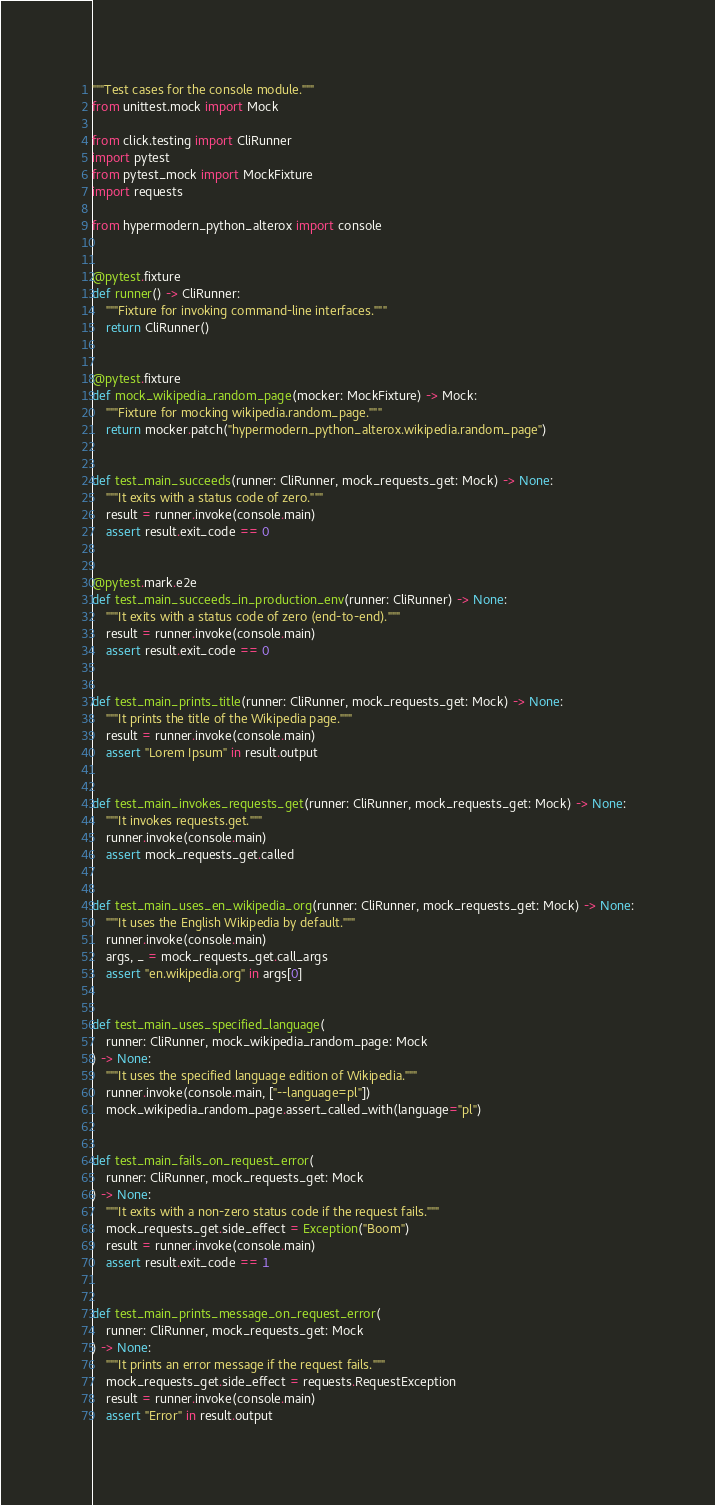Convert code to text. <code><loc_0><loc_0><loc_500><loc_500><_Python_>"""Test cases for the console module."""
from unittest.mock import Mock

from click.testing import CliRunner
import pytest
from pytest_mock import MockFixture
import requests

from hypermodern_python_alterox import console


@pytest.fixture
def runner() -> CliRunner:
    """Fixture for invoking command-line interfaces."""
    return CliRunner()


@pytest.fixture
def mock_wikipedia_random_page(mocker: MockFixture) -> Mock:
    """Fixture for mocking wikipedia.random_page."""
    return mocker.patch("hypermodern_python_alterox.wikipedia.random_page")


def test_main_succeeds(runner: CliRunner, mock_requests_get: Mock) -> None:
    """It exits with a status code of zero."""
    result = runner.invoke(console.main)
    assert result.exit_code == 0


@pytest.mark.e2e
def test_main_succeeds_in_production_env(runner: CliRunner) -> None:
    """It exits with a status code of zero (end-to-end)."""
    result = runner.invoke(console.main)
    assert result.exit_code == 0


def test_main_prints_title(runner: CliRunner, mock_requests_get: Mock) -> None:
    """It prints the title of the Wikipedia page."""
    result = runner.invoke(console.main)
    assert "Lorem Ipsum" in result.output


def test_main_invokes_requests_get(runner: CliRunner, mock_requests_get: Mock) -> None:
    """It invokes requests.get."""
    runner.invoke(console.main)
    assert mock_requests_get.called


def test_main_uses_en_wikipedia_org(runner: CliRunner, mock_requests_get: Mock) -> None:
    """It uses the English Wikipedia by default."""
    runner.invoke(console.main)
    args, _ = mock_requests_get.call_args
    assert "en.wikipedia.org" in args[0]


def test_main_uses_specified_language(
    runner: CliRunner, mock_wikipedia_random_page: Mock
) -> None:
    """It uses the specified language edition of Wikipedia."""
    runner.invoke(console.main, ["--language=pl"])
    mock_wikipedia_random_page.assert_called_with(language="pl")


def test_main_fails_on_request_error(
    runner: CliRunner, mock_requests_get: Mock
) -> None:
    """It exits with a non-zero status code if the request fails."""
    mock_requests_get.side_effect = Exception("Boom")
    result = runner.invoke(console.main)
    assert result.exit_code == 1


def test_main_prints_message_on_request_error(
    runner: CliRunner, mock_requests_get: Mock
) -> None:
    """It prints an error message if the request fails."""
    mock_requests_get.side_effect = requests.RequestException
    result = runner.invoke(console.main)
    assert "Error" in result.output
</code> 